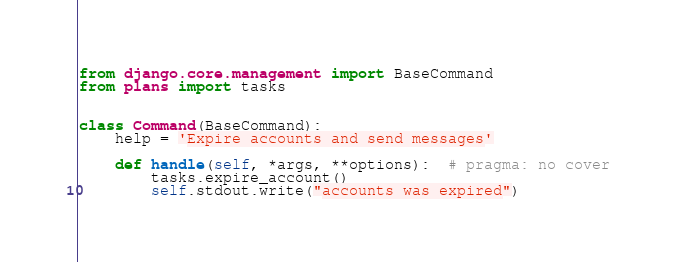Convert code to text. <code><loc_0><loc_0><loc_500><loc_500><_Python_>from django.core.management import BaseCommand
from plans import tasks


class Command(BaseCommand):
    help = 'Expire accounts and send messages'

    def handle(self, *args, **options):  # pragma: no cover
        tasks.expire_account()
        self.stdout.write("accounts was expired")
</code> 